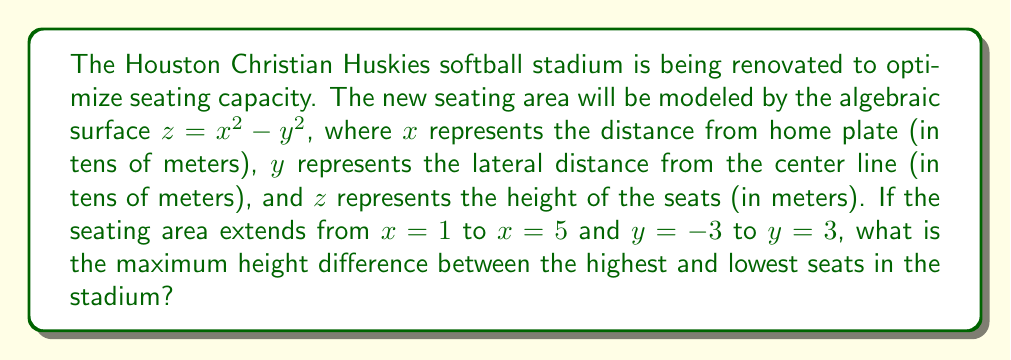Could you help me with this problem? Let's approach this step-by-step:

1) The surface is given by the equation $z = x^2 - y^2$.

2) We need to find the maximum and minimum values of $z$ within the given bounds:
   $1 \leq x \leq 5$ and $-3 \leq y \leq 3$

3) To find the extrema, we need to check:
   a) The corners of the domain
   b) Any critical points within the domain

4) The corners of the domain are:
   $(1, -3)$, $(1, 3)$, $(5, -3)$, $(5, 3)$

5) Evaluating $z$ at these points:
   $z(1, -3) = 1^2 - (-3)^2 = 1 - 9 = -8$
   $z(1, 3) = 1^2 - 3^2 = 1 - 9 = -8$
   $z(5, -3) = 5^2 - (-3)^2 = 25 - 9 = 16$
   $z(5, 3) = 5^2 - 3^2 = 25 - 9 = 16$

6) For critical points, we need to find where $\frac{\partial z}{\partial x} = \frac{\partial z}{\partial y} = 0$:
   $\frac{\partial z}{\partial x} = 2x = 0$ (not in our domain)
   $\frac{\partial z}{\partial y} = -2y = 0$ (when $y = 0$)

7) The line $y = 0$ within our domain gives:
   $z = x^2$ for $1 \leq x \leq 5$
   This reaches its maximum at $x = 5$, giving $z = 25$

8) Therefore, the maximum $z$ value is 25 (at $(5, 0)$) and the minimum is -8 (at $(1, \pm 3)$).

9) The height difference is $25 - (-8) = 33$ meters.
Answer: 33 meters 